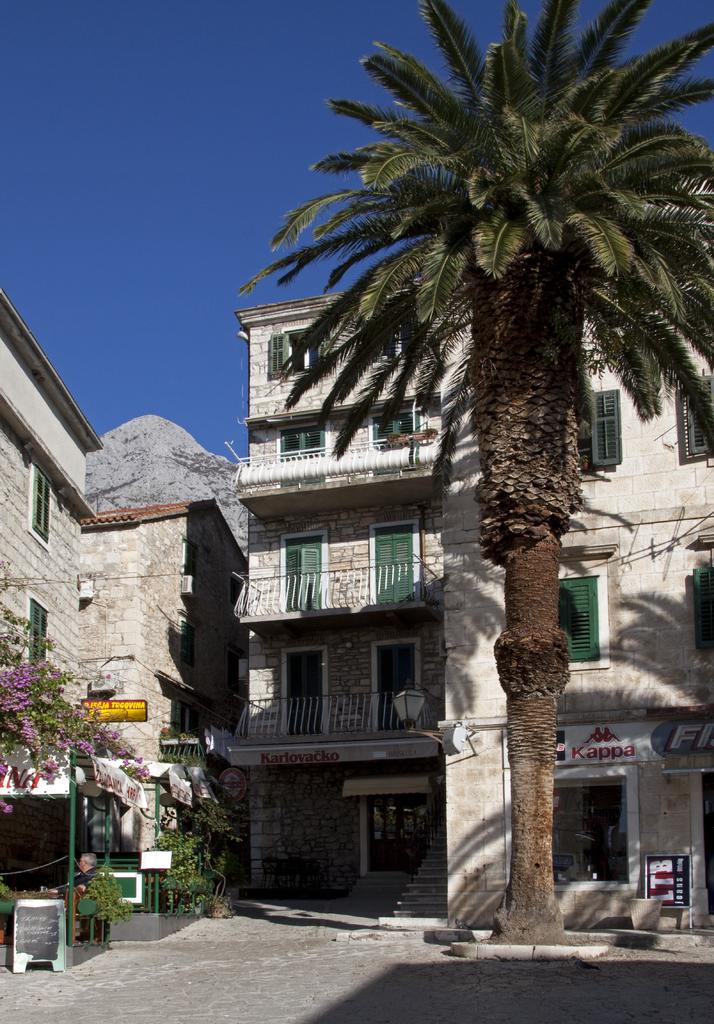What is the clothing brand featured on the white sign on the right?
Your response must be concise. Kappa. How many floors does the building have?
Your answer should be compact. Answering does not require reading text in the image. 